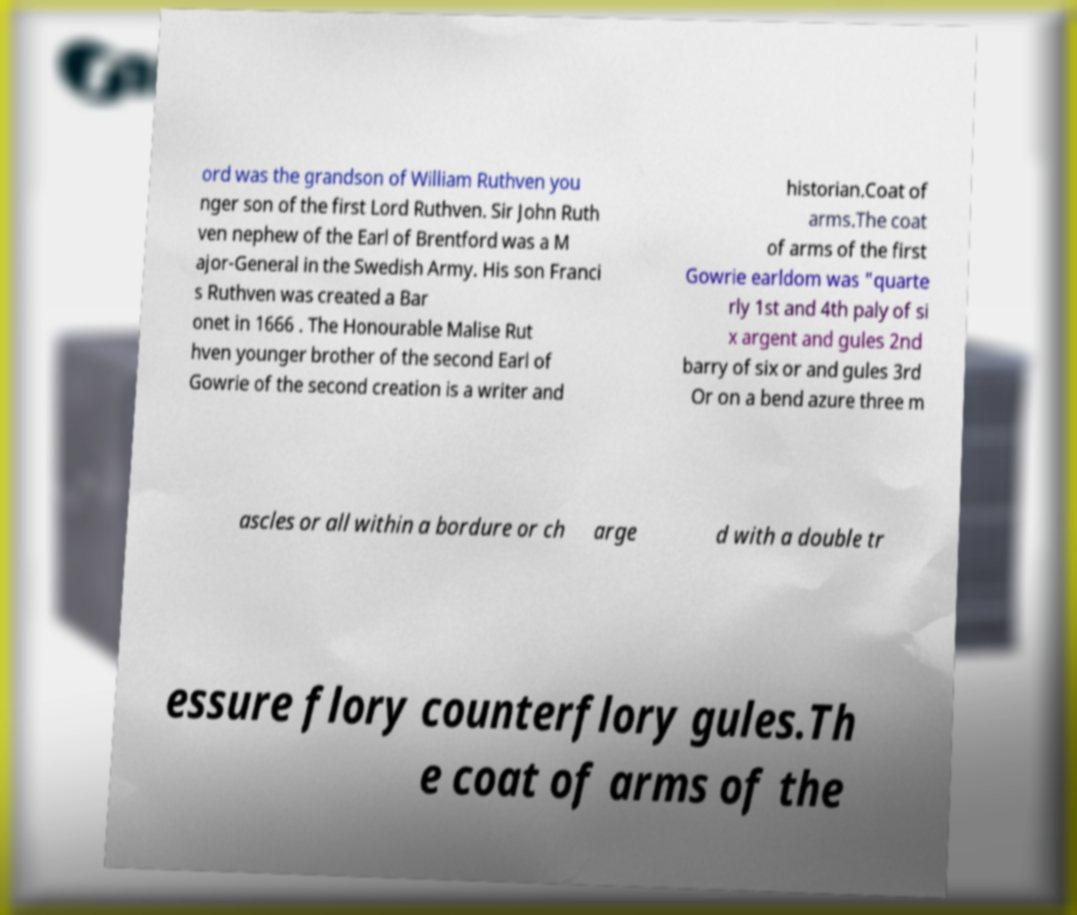Could you extract and type out the text from this image? ord was the grandson of William Ruthven you nger son of the first Lord Ruthven. Sir John Ruth ven nephew of the Earl of Brentford was a M ajor-General in the Swedish Army. His son Franci s Ruthven was created a Bar onet in 1666 . The Honourable Malise Rut hven younger brother of the second Earl of Gowrie of the second creation is a writer and historian.Coat of arms.The coat of arms of the first Gowrie earldom was "quarte rly 1st and 4th paly of si x argent and gules 2nd barry of six or and gules 3rd Or on a bend azure three m ascles or all within a bordure or ch arge d with a double tr essure flory counterflory gules.Th e coat of arms of the 